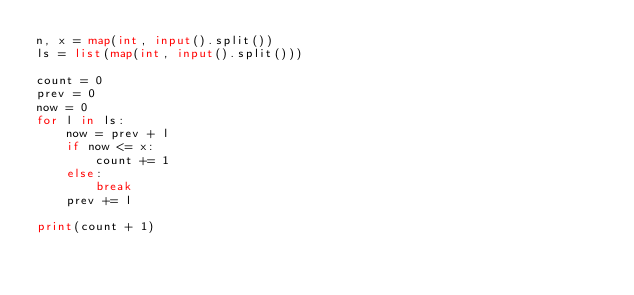<code> <loc_0><loc_0><loc_500><loc_500><_Python_>n, x = map(int, input().split())
ls = list(map(int, input().split()))

count = 0
prev = 0
now = 0
for l in ls:
    now = prev + l
    if now <= x:
        count += 1
    else:
        break
    prev += l

print(count + 1)</code> 